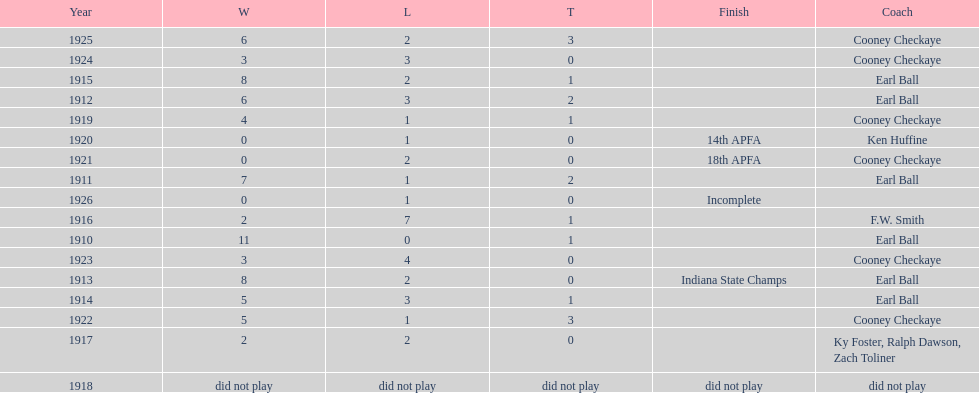In what year did the muncie flyers have an undefeated record? 1910. 